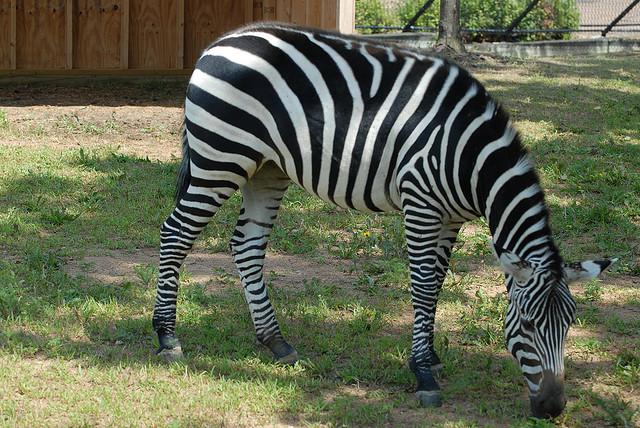What is the zebra doing?
Give a very brief answer. Grazing. Does the grass look healthy?
Give a very brief answer. No. Are the zebras colors well defined?
Write a very short answer. Yes. 